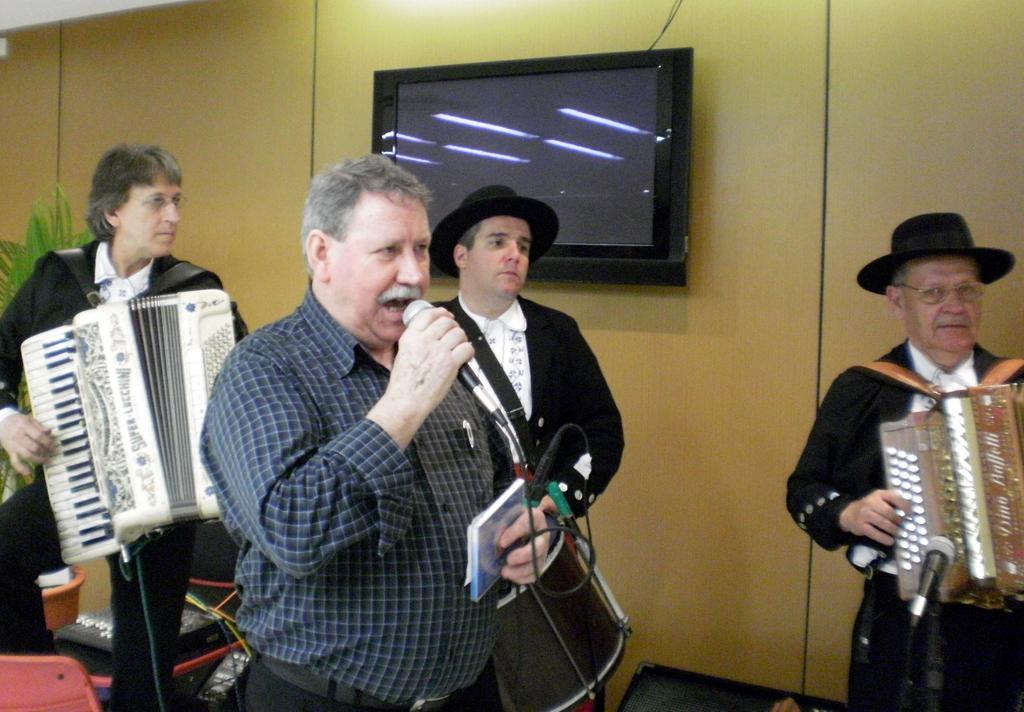Describe this image in one or two sentences. In this image I can see in the middle a man is standing and singing in the microphone, he wore shirt, trouser. Behind him there is a man operating the musical instrument, in the middle there is the t. v. to the wall. On the right side there is an old man, he wore black color dress and a hat. 